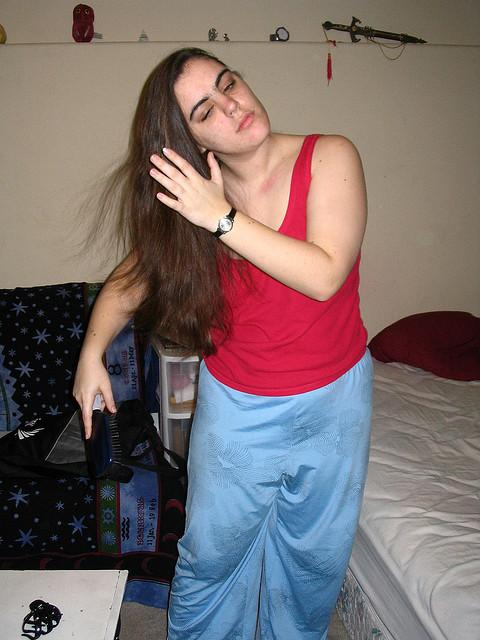What item hanging on the wall would help most on a battlefield?

Choices:
A) blunderbuss
B) bazooka
C) dagger
D) watch dagger 